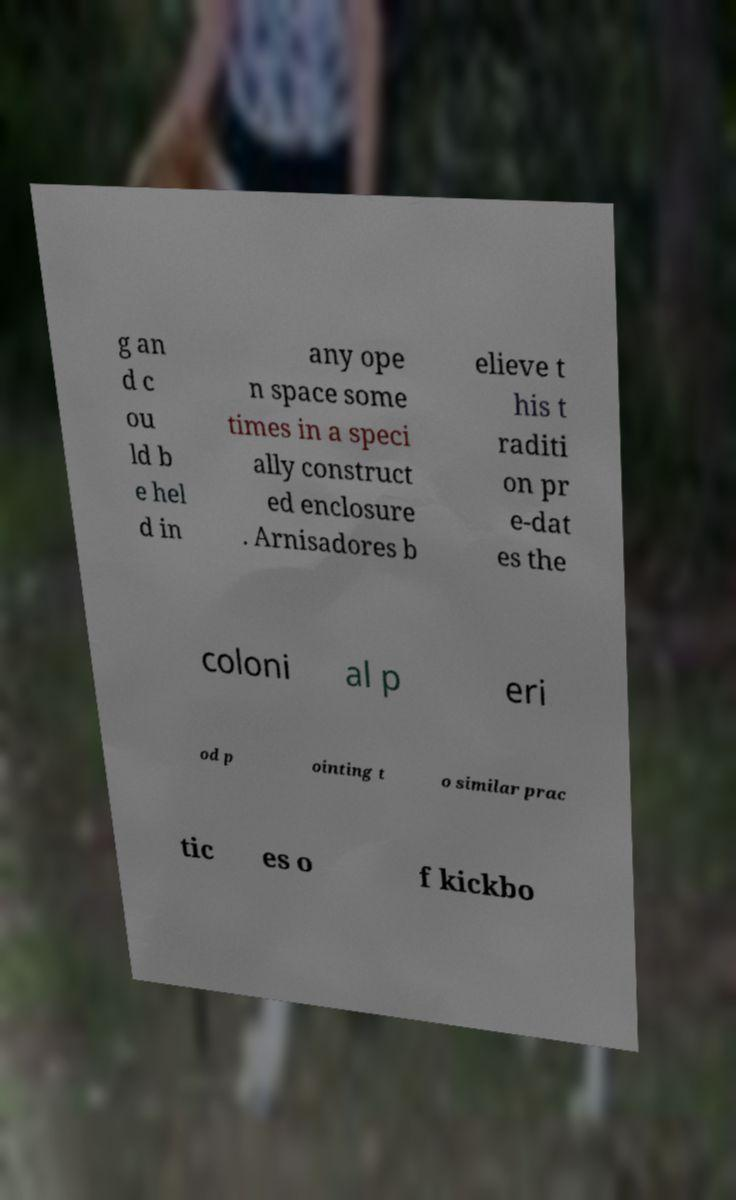Can you read and provide the text displayed in the image?This photo seems to have some interesting text. Can you extract and type it out for me? g an d c ou ld b e hel d in any ope n space some times in a speci ally construct ed enclosure . Arnisadores b elieve t his t raditi on pr e-dat es the coloni al p eri od p ointing t o similar prac tic es o f kickbo 